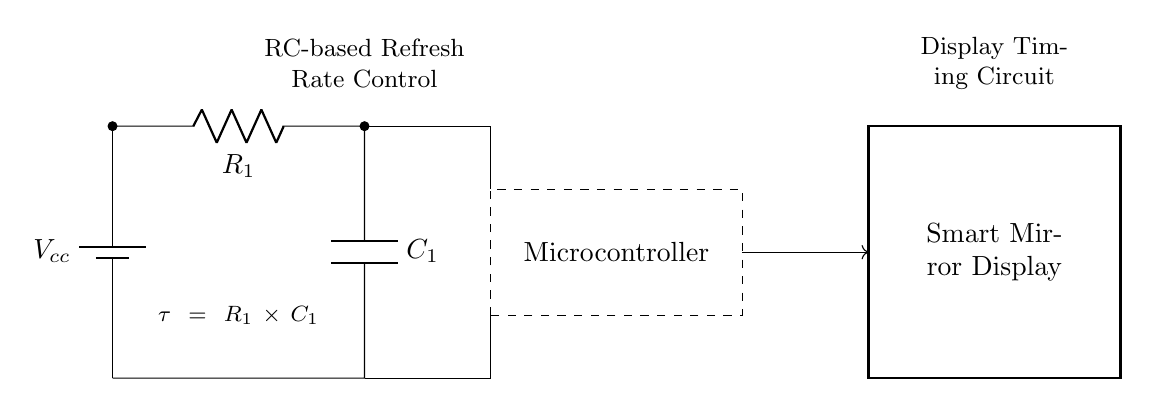What is the value of the resistor in this circuit? The resistor labeled R1 in the circuit is represented as a variable. Without specific numerical data given, we cannot determine an exact value.
Answer: R1 What is the capacitance of the capacitor in this circuit? The capacitor labeled C1 is also variable like R1, indicating that we don't have a specific value here either, just a placeholder.
Answer: C1 What is the function of the microcontroller in this circuit? The microcontroller processes the signal from the RC circuit and controls the timing for the smart mirror display. It is an integral component for refreshing the display at the right rate.
Answer: Timing control What does the time constant formula represent in this circuit? The formula shown, tau equals R1 times C1, indicates the time constant of the RC circuit, which determines how quickly the capacitor charges and discharges. This affects the response time of the display refresh rate.
Answer: Charging rate How does changing R1 affect the timing of the display? If resistance R1 is increased, the time constant tau increases, meaning it takes longer for the capacitor to charge and discharge, which slows down the refresh rate of the display. Conversely, reducing R1 will lead to a quicker refresh rate.
Answer: Increases refresh rate What is the role of the battery in this circuit? The battery provides the necessary voltage supply to the entire circuit to operate, ensuring that both the RC circuit and the microcontroller have power to function correctly.
Answer: Power source What type of circuit is shown in this diagram? This circuit is an RC timing circuit specifically designed to control the refresh rate for a smart mirror display through the interaction of resistors and capacitors.
Answer: RC timing circuit 